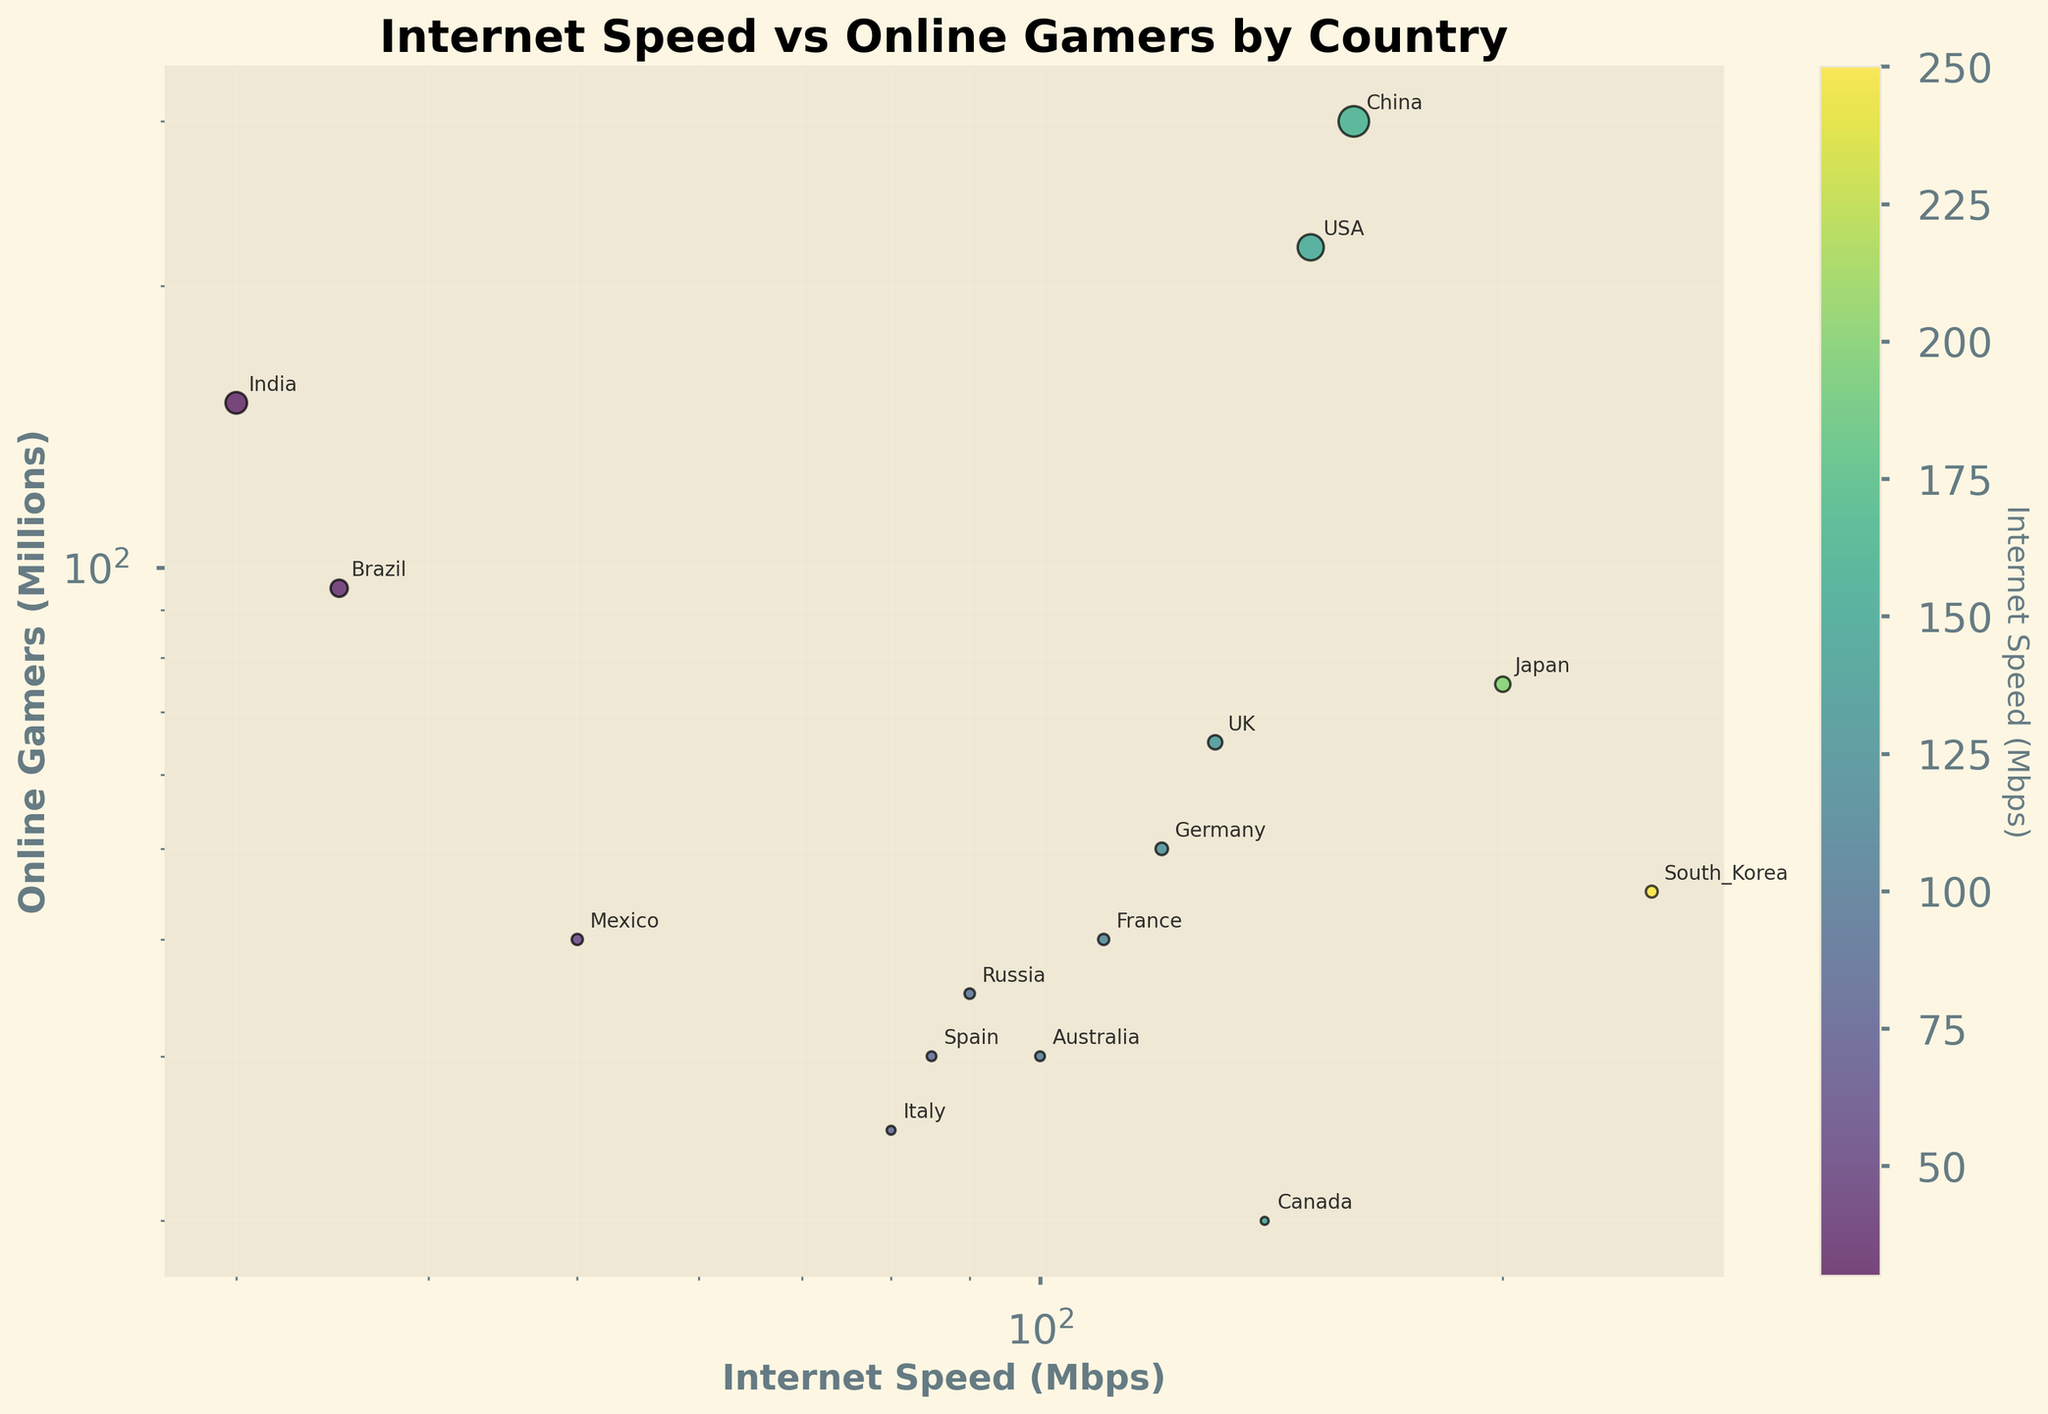What is the title of the scatter plot? The title is usually located at the top of the scatter plot and summarizes the main subject of the graph.
Answer: Internet Speed vs Online Gamers by Country Which country has the highest number of online gamers? The country with the highest number of online gamers will be the one with the highest y-value on the log scale axis for online gamers.
Answer: China What internet speed range does the color bar cover? The color bar on the right side of the plot indicates the internet speed in Mbps, represented by a gradient from lighter to darker colors.
Answer: 30 Mbps to 250 Mbps What are the axes labels? The labels describe what each axis represents and are typically located near the axes.
Answer: Internet Speed (Mbps) for the x-axis and Online Gamers (Millions) for the y-axis Which country has the lowest internet speed but relatively high number of online gamers? Look for the country that is positioned on the leftmost side of the plot (low x-value) but still relatively high on the y-axis.
Answer: India Which countries have more than 100 million online gamers? Identify the countries with y-values greater than 100 million.
Answer: USA, China, India What is the relationship between internet speed and the number of online gamers? Is there a trend? Analyze the scatter plot to see if there's a visible pattern or correlation between the x-values (internet speeds) and y-values (number of online gamers).
Answer: Generally, there is no strong correlation; countries with high or low internet speeds may have a varying number of online gamers How does the number of online gamers in Germany compare to that of France? Identify the y-values for Germany and France and compare them directly.
Answer: Germany has more online gamers than France What is the average internet speed of the countries plotted? Sum the internet speeds of all the countries and divide by the number of countries. Calculation: (150+200+250+120+130+110+35+30+160+100+140+90+50+80+85)/15 = 123.67
Answer: 123.67 Mbps Which country has the smallest bubble size, and what does that represent? The bubble size represents the number of online gamers; the smallest bubble corresponds to the country with the least number of online gamers.
Answer: Canada 